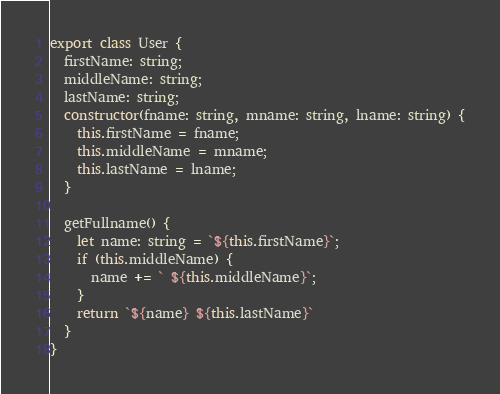<code> <loc_0><loc_0><loc_500><loc_500><_TypeScript_>export class User {
  firstName: string;
  middleName: string;
  lastName: string;
  constructor(fname: string, mname: string, lname: string) {
    this.firstName = fname;
    this.middleName = mname;
    this.lastName = lname;
  }

  getFullname() {
    let name: string = `${this.firstName}`;
    if (this.middleName) {
      name += ` ${this.middleName}`;
    }
    return `${name} ${this.lastName}`
  }
}
</code> 